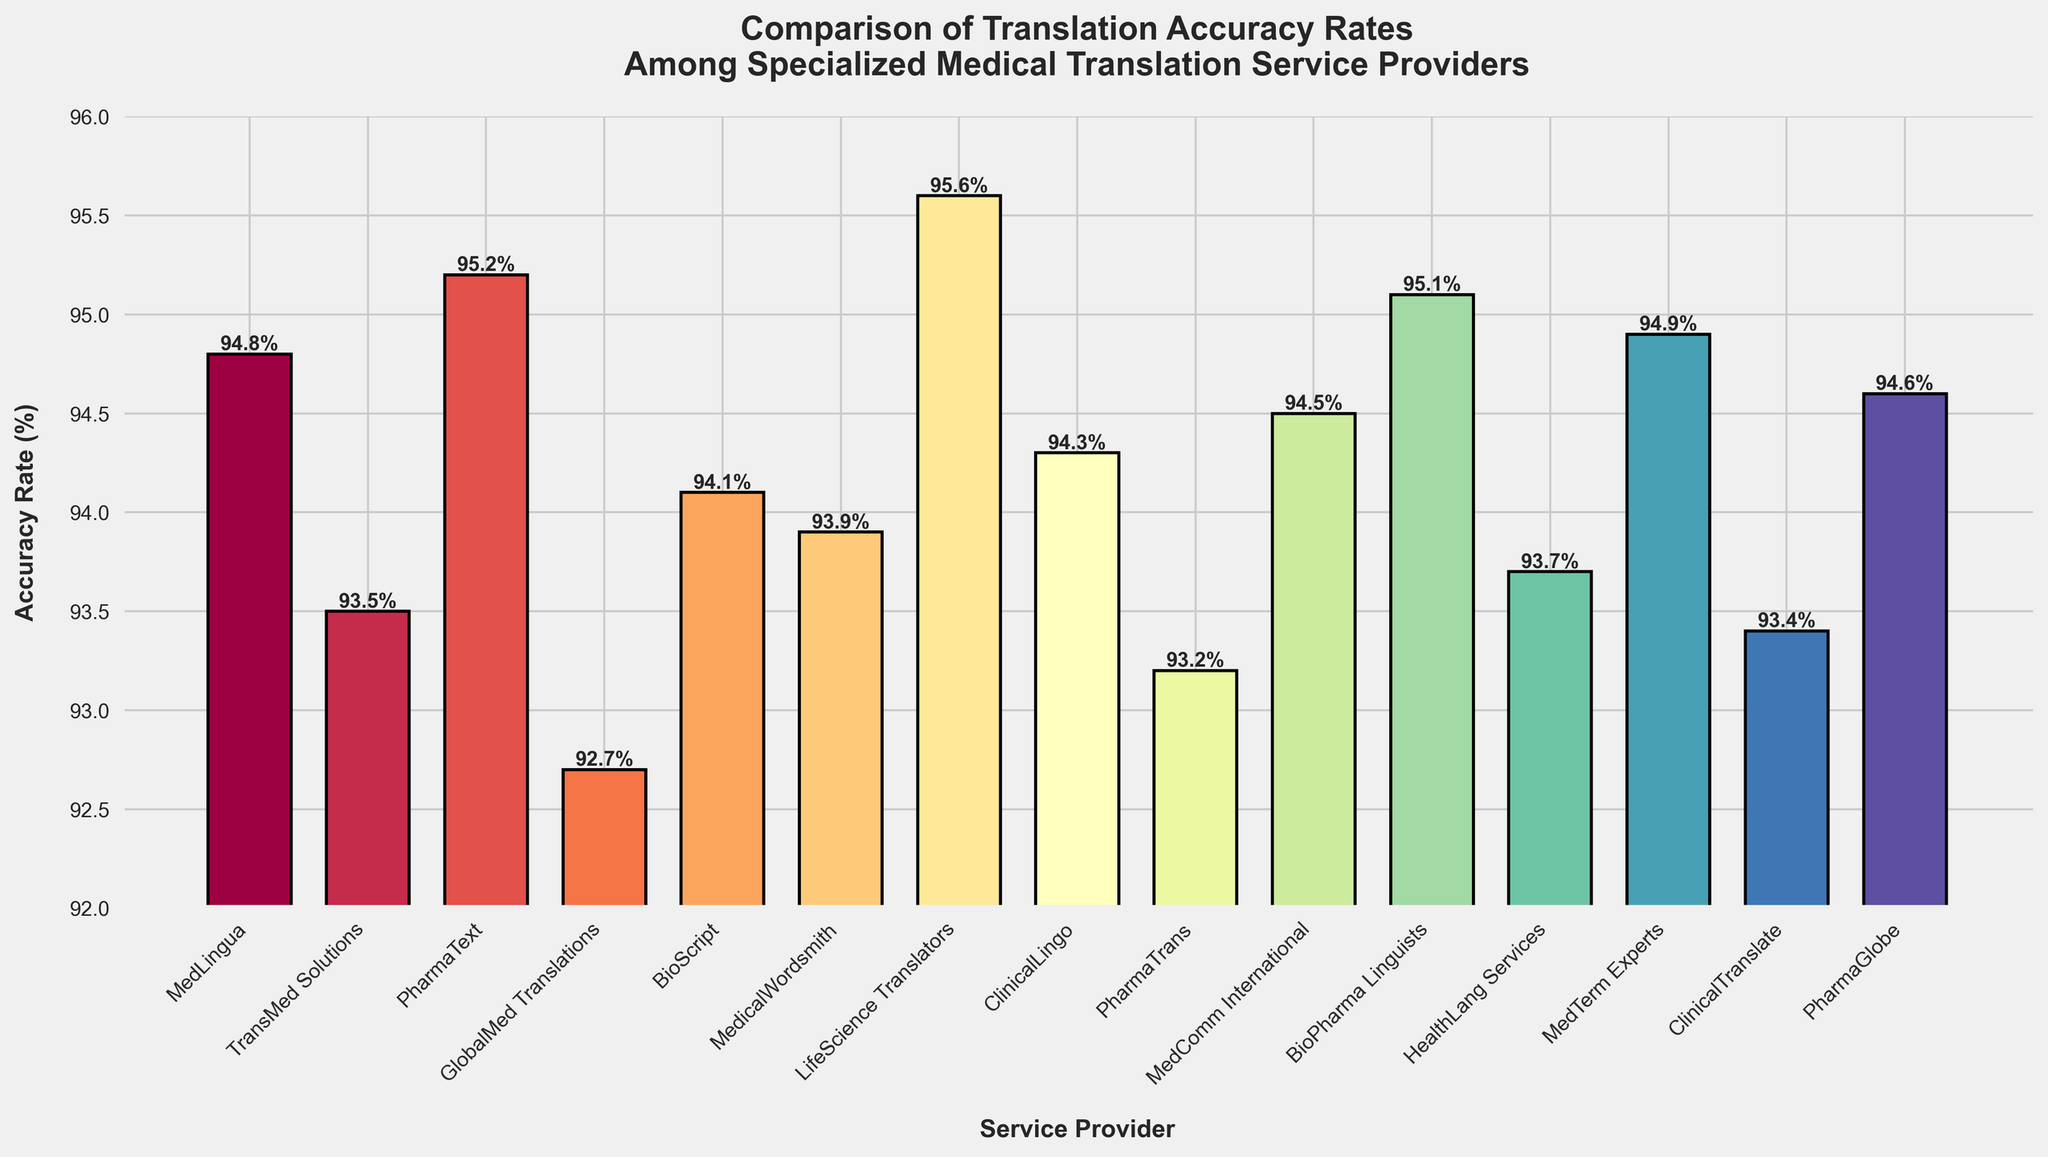Which service provider has the highest translation accuracy rate? The figure shows bars representing accuracy rates for different service providers. The highest bar corresponds to LifeScience Translators with an accuracy rate of 95.6%.
Answer: LifeScience Translators What is the difference in accuracy rate between PharmaText and BioScript? PharmaText has an accuracy rate of 95.2% and BioScript has 94.1%. The difference can be calculated as 95.2 - 94.1 = 1.1%.
Answer: 1.1% Which service provider ranks third in translation accuracy rate? To find the third highest accuracy rate, we look for the third tallest bar. The third highest bar corresponds to BioPharma Linguists with an accuracy rate of 95.1%.
Answer: BioPharma Linguists How many service providers have an accuracy rate greater than 94% but less than 95%? By observing the height of the bars, we find that MedLingua, BioScript, and MedComm International fall into this range.
Answer: 3 What is the average accuracy rate of the three least accurate service providers? The three service providers with the lowest accuracy rates are GlobalMed Translations (92.7%), PharmaTrans (93.2%), and ClinicalTranslate (93.4%). The average is calculated as (92.7 + 93.2 + 93.4)/3 = 93.1%.
Answer: 93.1% Is MedicalWordsmith's accuracy rate greater than the average accuracy rate of all service providers? First, calculate the average accuracy rate of all 15 service providers. Sum all the rates and divide by 15: (94.8 + 93.5 + 95.2 + 92.7 + 94.1 + 93.9 + 95.6 + 94.3 + 93.2 + 94.5 + 95.1 + 93.7 + 94.9 + 93.4 + 94.6)/15 = 94.19%. Then compare with MedicalWordsmith's rate of 93.9%.
Answer: No Which service provider has a visually distinctive bar color at the end of the spectrum? The figure uses the Spectral colormap, where the colors range from one end of the spectrum to another. The bar for LifeScience Translators stands out with a distinctive color because it is positioned as the highest accuracy rate.
Answer: LifeScience Translators What is the combined accuracy rate of MedLingua, MedicalWordsmith, and ClinicalLingo? Sum their accuracy rates: MedLingua (94.8%), MedicalWordsmith (93.9%), and ClinicalLingo (94.3%). Combined rate is 94.8 + 93.9 + 94.3 = 283%.
Answer: 283% Are there more service providers with an accuracy rate above 94% compared to those below 94%? By counting, there are 10 service providers with accuracy rates above 94% and 5 with below 94%. Thus, more providers have rates above 94%.
Answer: Yes Does PharmaGlobe have a higher accuracy rate than MedComm International? The accuracy rate for PharmaGlobe is 94.6%, and for MedComm International it is 94.5%. Hence, PharmaGlobe's rate is higher.
Answer: Yes 